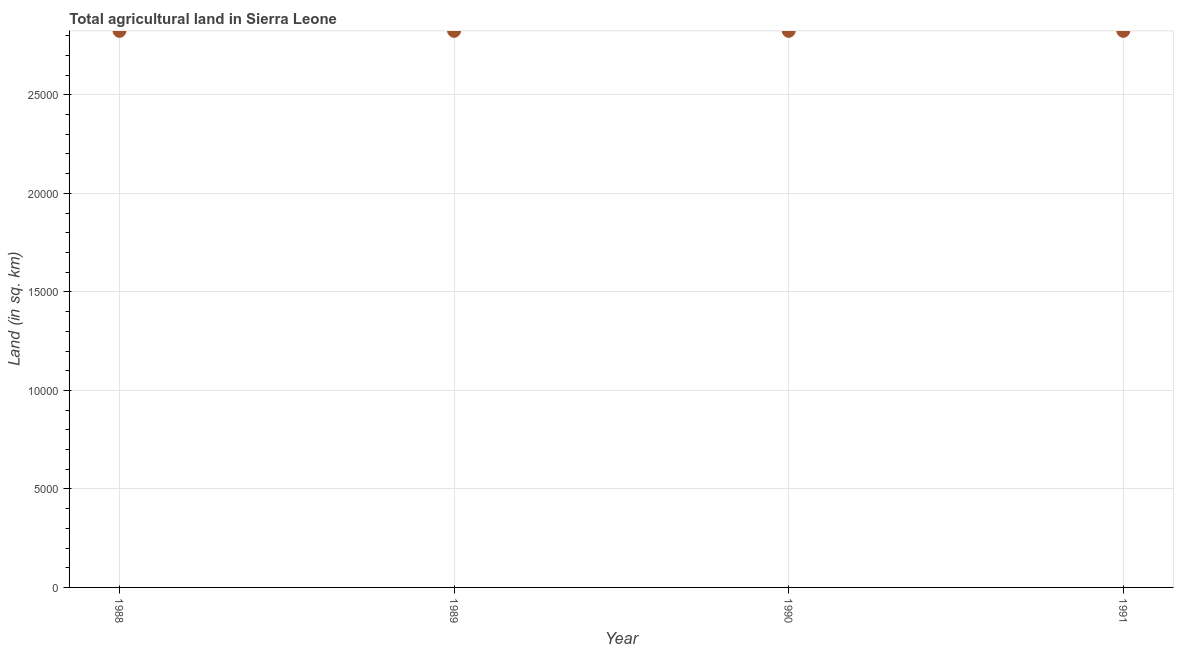What is the agricultural land in 1990?
Make the answer very short. 2.82e+04. Across all years, what is the maximum agricultural land?
Provide a succinct answer. 2.82e+04. Across all years, what is the minimum agricultural land?
Offer a very short reply. 2.82e+04. What is the sum of the agricultural land?
Your answer should be compact. 1.13e+05. What is the difference between the agricultural land in 1990 and 1991?
Ensure brevity in your answer.  0. What is the average agricultural land per year?
Your response must be concise. 2.82e+04. What is the median agricultural land?
Your response must be concise. 2.82e+04. In how many years, is the agricultural land greater than 19000 sq. km?
Give a very brief answer. 4. Do a majority of the years between 1991 and 1989 (inclusive) have agricultural land greater than 19000 sq. km?
Give a very brief answer. No. Is the difference between the agricultural land in 1988 and 1990 greater than the difference between any two years?
Offer a terse response. Yes. Is the sum of the agricultural land in 1989 and 1991 greater than the maximum agricultural land across all years?
Your answer should be compact. Yes. Does the graph contain any zero values?
Provide a succinct answer. No. What is the title of the graph?
Offer a very short reply. Total agricultural land in Sierra Leone. What is the label or title of the X-axis?
Provide a short and direct response. Year. What is the label or title of the Y-axis?
Give a very brief answer. Land (in sq. km). What is the Land (in sq. km) in 1988?
Make the answer very short. 2.82e+04. What is the Land (in sq. km) in 1989?
Provide a short and direct response. 2.82e+04. What is the Land (in sq. km) in 1990?
Provide a succinct answer. 2.82e+04. What is the Land (in sq. km) in 1991?
Give a very brief answer. 2.82e+04. What is the difference between the Land (in sq. km) in 1988 and 1989?
Provide a short and direct response. 0. What is the difference between the Land (in sq. km) in 1988 and 1990?
Your response must be concise. 0. What is the difference between the Land (in sq. km) in 1988 and 1991?
Offer a terse response. 0. What is the difference between the Land (in sq. km) in 1989 and 1990?
Give a very brief answer. 0. What is the difference between the Land (in sq. km) in 1989 and 1991?
Your answer should be very brief. 0. What is the ratio of the Land (in sq. km) in 1988 to that in 1991?
Make the answer very short. 1. 